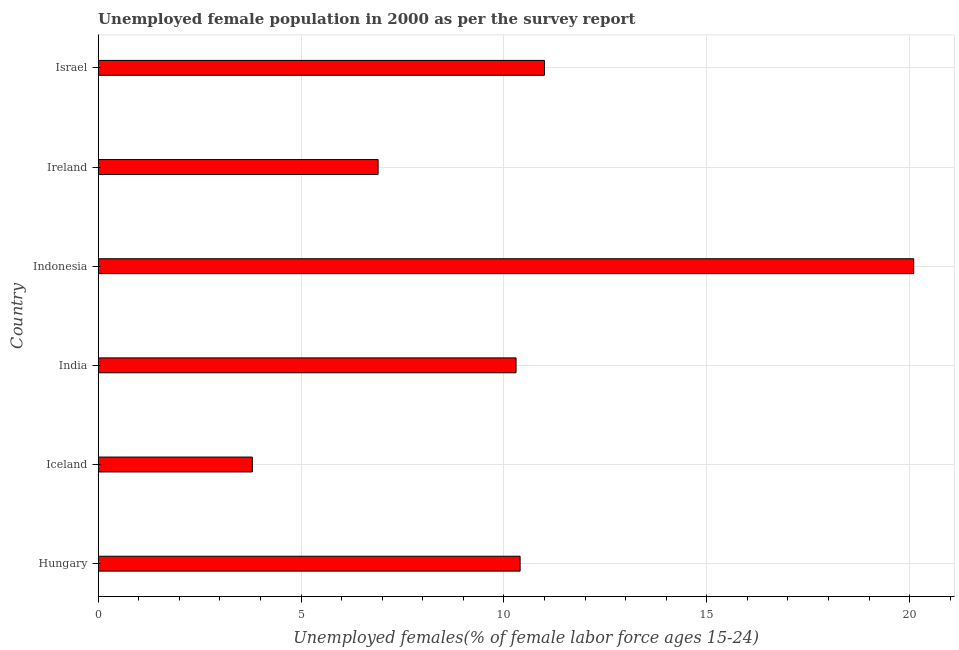Does the graph contain any zero values?
Your response must be concise. No. What is the title of the graph?
Ensure brevity in your answer.  Unemployed female population in 2000 as per the survey report. What is the label or title of the X-axis?
Your answer should be very brief. Unemployed females(% of female labor force ages 15-24). What is the label or title of the Y-axis?
Provide a short and direct response. Country. What is the unemployed female youth in Ireland?
Ensure brevity in your answer.  6.9. Across all countries, what is the maximum unemployed female youth?
Provide a succinct answer. 20.1. Across all countries, what is the minimum unemployed female youth?
Your answer should be very brief. 3.8. What is the sum of the unemployed female youth?
Offer a very short reply. 62.5. What is the average unemployed female youth per country?
Keep it short and to the point. 10.42. What is the median unemployed female youth?
Offer a very short reply. 10.35. In how many countries, is the unemployed female youth greater than 4 %?
Provide a short and direct response. 5. What is the ratio of the unemployed female youth in Hungary to that in Iceland?
Your answer should be compact. 2.74. Is the sum of the unemployed female youth in Iceland and Israel greater than the maximum unemployed female youth across all countries?
Keep it short and to the point. No. Are all the bars in the graph horizontal?
Your response must be concise. Yes. How many countries are there in the graph?
Offer a very short reply. 6. Are the values on the major ticks of X-axis written in scientific E-notation?
Your response must be concise. No. What is the Unemployed females(% of female labor force ages 15-24) in Hungary?
Ensure brevity in your answer.  10.4. What is the Unemployed females(% of female labor force ages 15-24) in Iceland?
Your response must be concise. 3.8. What is the Unemployed females(% of female labor force ages 15-24) in India?
Give a very brief answer. 10.3. What is the Unemployed females(% of female labor force ages 15-24) of Indonesia?
Keep it short and to the point. 20.1. What is the Unemployed females(% of female labor force ages 15-24) in Ireland?
Your response must be concise. 6.9. What is the difference between the Unemployed females(% of female labor force ages 15-24) in Hungary and India?
Your answer should be very brief. 0.1. What is the difference between the Unemployed females(% of female labor force ages 15-24) in Iceland and Indonesia?
Your answer should be very brief. -16.3. What is the difference between the Unemployed females(% of female labor force ages 15-24) in Iceland and Israel?
Provide a succinct answer. -7.2. What is the difference between the Unemployed females(% of female labor force ages 15-24) in India and Ireland?
Your response must be concise. 3.4. What is the difference between the Unemployed females(% of female labor force ages 15-24) in India and Israel?
Make the answer very short. -0.7. What is the difference between the Unemployed females(% of female labor force ages 15-24) in Indonesia and Ireland?
Give a very brief answer. 13.2. What is the difference between the Unemployed females(% of female labor force ages 15-24) in Ireland and Israel?
Your answer should be very brief. -4.1. What is the ratio of the Unemployed females(% of female labor force ages 15-24) in Hungary to that in Iceland?
Provide a short and direct response. 2.74. What is the ratio of the Unemployed females(% of female labor force ages 15-24) in Hungary to that in Indonesia?
Give a very brief answer. 0.52. What is the ratio of the Unemployed females(% of female labor force ages 15-24) in Hungary to that in Ireland?
Your answer should be compact. 1.51. What is the ratio of the Unemployed females(% of female labor force ages 15-24) in Hungary to that in Israel?
Your response must be concise. 0.94. What is the ratio of the Unemployed females(% of female labor force ages 15-24) in Iceland to that in India?
Offer a terse response. 0.37. What is the ratio of the Unemployed females(% of female labor force ages 15-24) in Iceland to that in Indonesia?
Offer a terse response. 0.19. What is the ratio of the Unemployed females(% of female labor force ages 15-24) in Iceland to that in Ireland?
Offer a very short reply. 0.55. What is the ratio of the Unemployed females(% of female labor force ages 15-24) in Iceland to that in Israel?
Provide a succinct answer. 0.34. What is the ratio of the Unemployed females(% of female labor force ages 15-24) in India to that in Indonesia?
Provide a short and direct response. 0.51. What is the ratio of the Unemployed females(% of female labor force ages 15-24) in India to that in Ireland?
Your response must be concise. 1.49. What is the ratio of the Unemployed females(% of female labor force ages 15-24) in India to that in Israel?
Ensure brevity in your answer.  0.94. What is the ratio of the Unemployed females(% of female labor force ages 15-24) in Indonesia to that in Ireland?
Make the answer very short. 2.91. What is the ratio of the Unemployed females(% of female labor force ages 15-24) in Indonesia to that in Israel?
Make the answer very short. 1.83. What is the ratio of the Unemployed females(% of female labor force ages 15-24) in Ireland to that in Israel?
Ensure brevity in your answer.  0.63. 